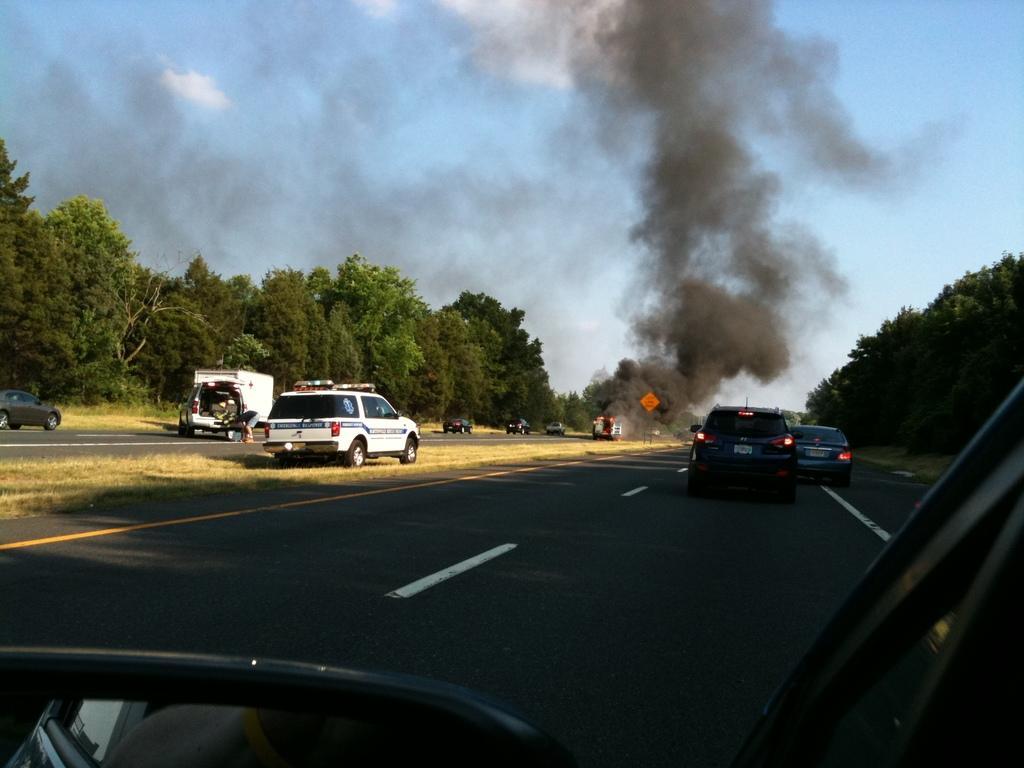Can you describe this image briefly? This picture is clicked outside the city. In this picture, we see many vehicles are moving on the road. At the bottom of the picture, we see the front mirror of the vehicle. There are trees on either side of the picture. In the middle of the picture, we see an orange color board and the smoke emitted from the vehicles. At the top of the picture, we see the sky. 